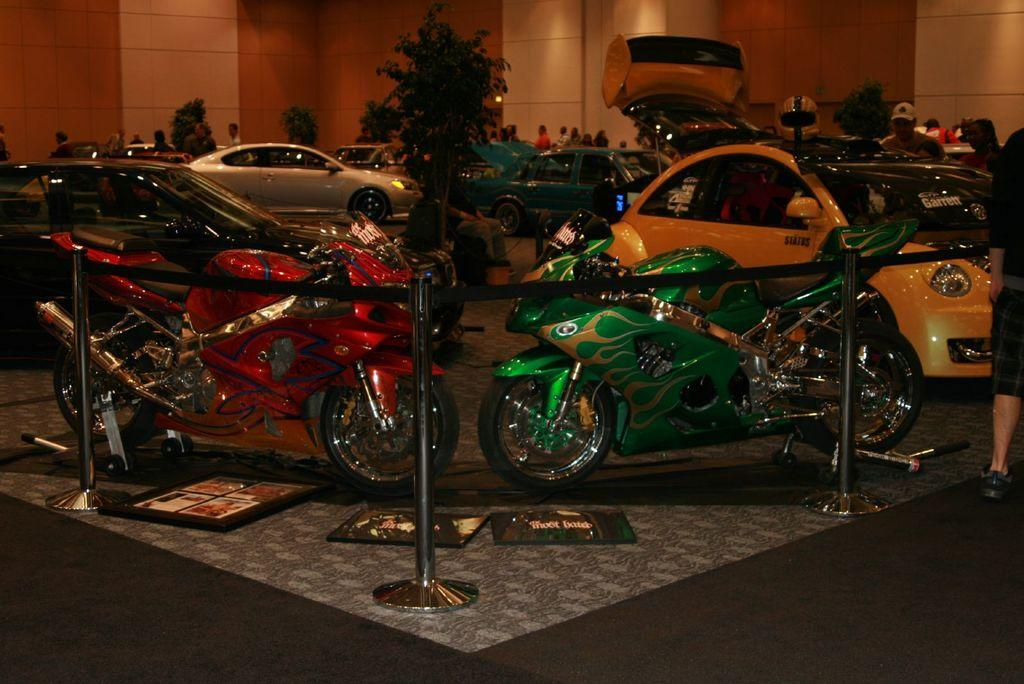What type of vehicles can be seen in the image? There are motorbikes and cars in the image. What are the people in the image doing? The people in the image are standing on the roads. What structures can be seen in the image? There are poles and a wall visible in the image. What type of vegetation is present in the image? There are trees in the image. What type of scientific experiment is being conducted on the patch of land in the image? There is no scientific experiment or patch of land visible in the image. 